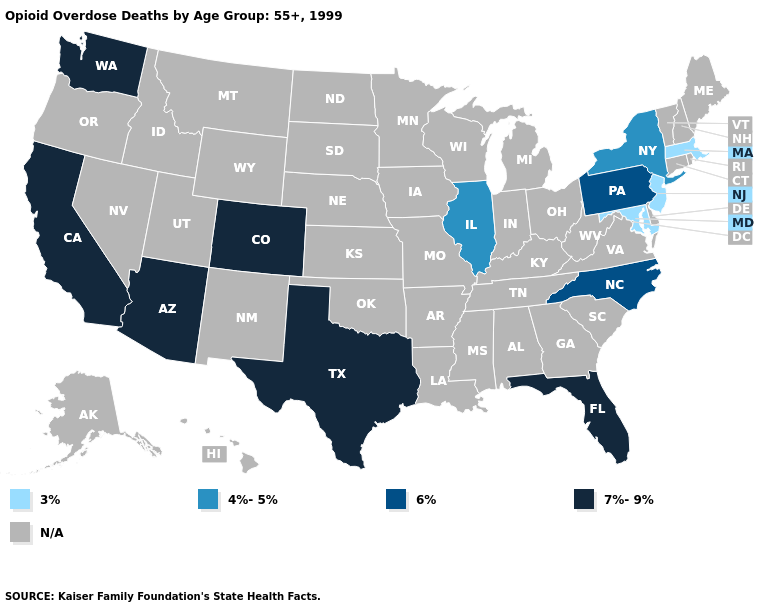Name the states that have a value in the range 4%-5%?
Quick response, please. Illinois, New York. Does the first symbol in the legend represent the smallest category?
Give a very brief answer. Yes. What is the value of Connecticut?
Quick response, please. N/A. Name the states that have a value in the range N/A?
Give a very brief answer. Alabama, Alaska, Arkansas, Connecticut, Delaware, Georgia, Hawaii, Idaho, Indiana, Iowa, Kansas, Kentucky, Louisiana, Maine, Michigan, Minnesota, Mississippi, Missouri, Montana, Nebraska, Nevada, New Hampshire, New Mexico, North Dakota, Ohio, Oklahoma, Oregon, Rhode Island, South Carolina, South Dakota, Tennessee, Utah, Vermont, Virginia, West Virginia, Wisconsin, Wyoming. What is the value of Washington?
Quick response, please. 7%-9%. Among the states that border Pennsylvania , which have the highest value?
Give a very brief answer. New York. What is the value of West Virginia?
Write a very short answer. N/A. What is the value of New Hampshire?
Quick response, please. N/A. Name the states that have a value in the range 7%-9%?
Keep it brief. Arizona, California, Colorado, Florida, Texas, Washington. Name the states that have a value in the range 4%-5%?
Be succinct. Illinois, New York. Does Maryland have the highest value in the South?
Give a very brief answer. No. Does Massachusetts have the highest value in the Northeast?
Concise answer only. No. Which states have the lowest value in the USA?
Short answer required. Maryland, Massachusetts, New Jersey. 